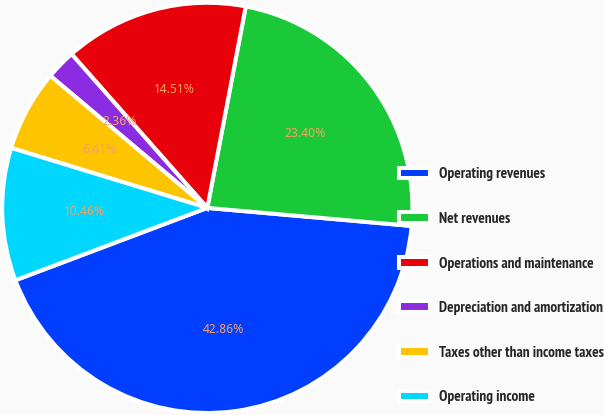<chart> <loc_0><loc_0><loc_500><loc_500><pie_chart><fcel>Operating revenues<fcel>Net revenues<fcel>Operations and maintenance<fcel>Depreciation and amortization<fcel>Taxes other than income taxes<fcel>Operating income<nl><fcel>42.86%<fcel>23.4%<fcel>14.51%<fcel>2.36%<fcel>6.41%<fcel>10.46%<nl></chart> 